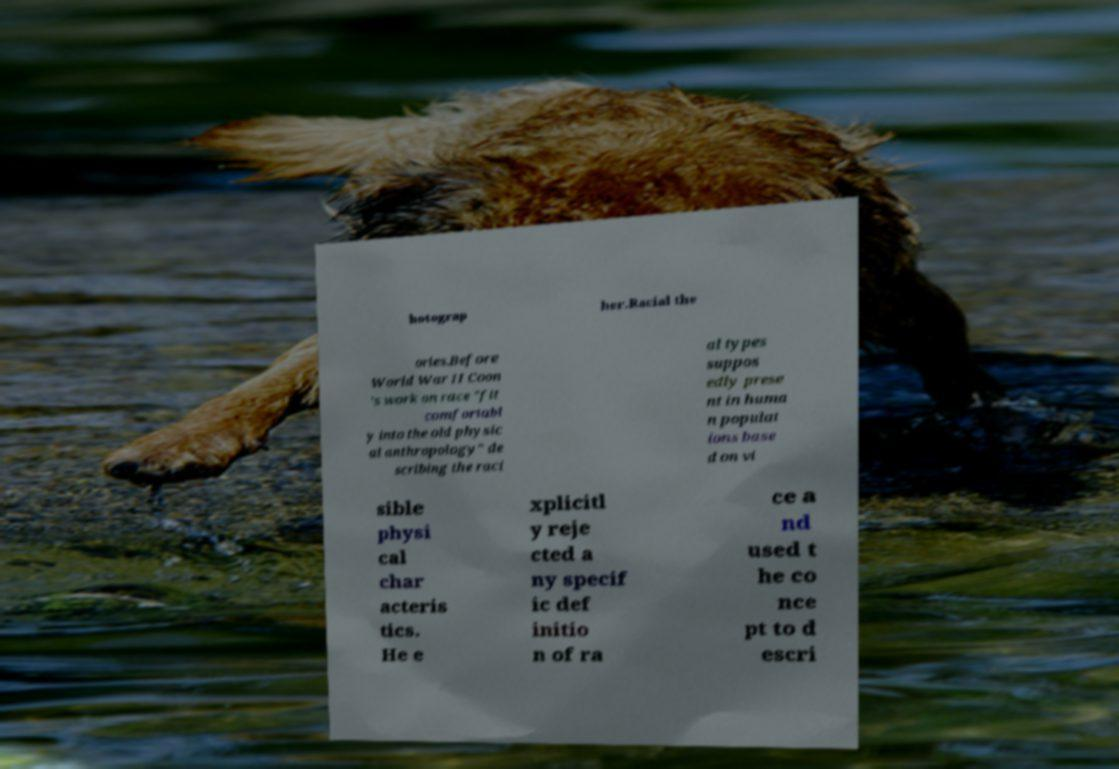There's text embedded in this image that I need extracted. Can you transcribe it verbatim? hotograp her.Racial the ories.Before World War II Coon 's work on race "fit comfortabl y into the old physic al anthropology" de scribing the raci al types suppos edly prese nt in huma n populat ions base d on vi sible physi cal char acteris tics. He e xplicitl y reje cted a ny specif ic def initio n of ra ce a nd used t he co nce pt to d escri 